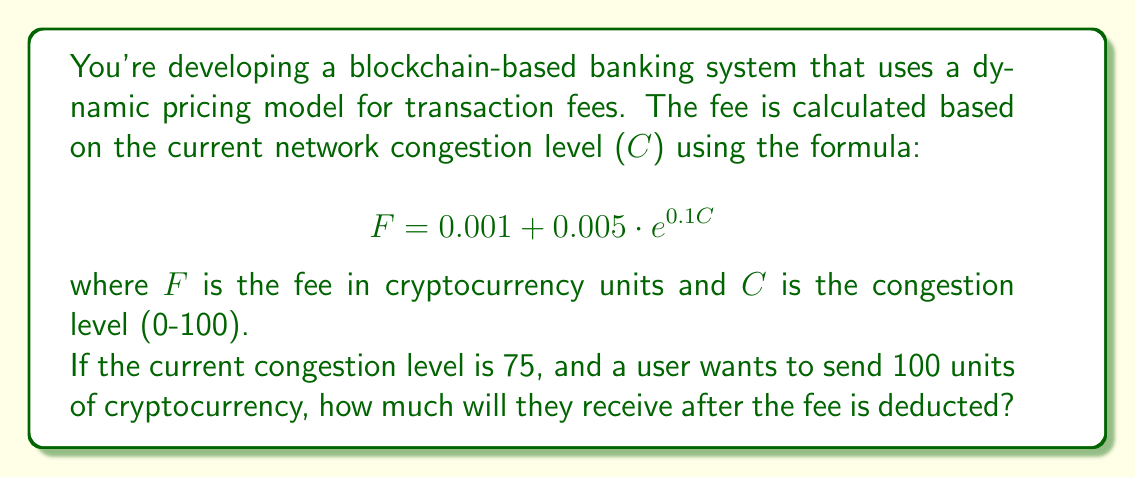Teach me how to tackle this problem. To solve this problem, we need to follow these steps:

1. Calculate the transaction fee (F) using the given formula and congestion level.
2. Subtract the fee from the total amount being sent.

Step 1: Calculating the transaction fee

We're given that the congestion level (C) is 75. Let's substitute this into the formula:

$$F = 0.001 + 0.005 \cdot e^{0.1 \cdot 75}$$

Now, let's calculate this step-by-step:

$$\begin{align}
F &= 0.001 + 0.005 \cdot e^{7.5} \\
&= 0.001 + 0.005 \cdot 1808.04 \\
&= 0.001 + 9.0402 \\
&= 9.0412
\end{align}$$

Step 2: Subtracting the fee from the total amount

The user wants to send 100 units of cryptocurrency. After deducting the fee, they will receive:

$$\begin{align}
\text{Amount received} &= \text{Total amount} - \text{Fee} \\
&= 100 - 9.0412 \\
&= 90.9588 \text{ units}
\end{align}$$
Answer: The user will receive 90.9588 units of cryptocurrency after the fee is deducted. 